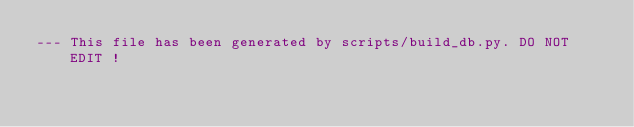Convert code to text. <code><loc_0><loc_0><loc_500><loc_500><_SQL_>--- This file has been generated by scripts/build_db.py. DO NOT EDIT !
</code> 